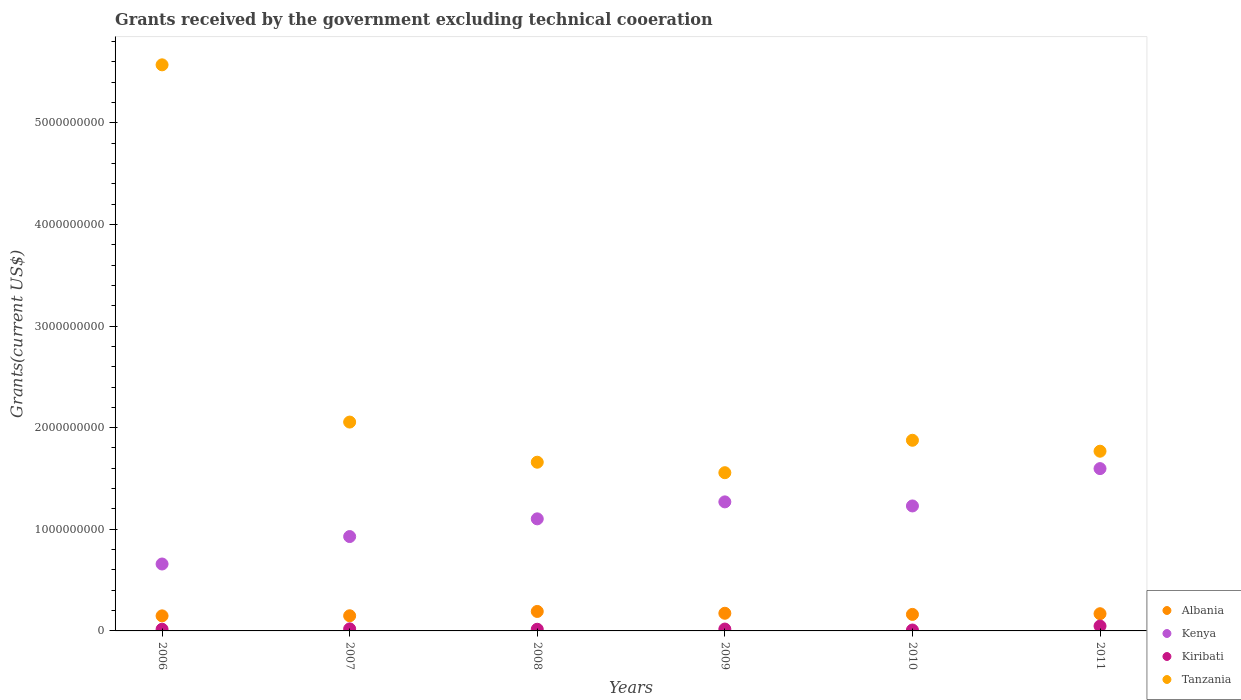How many different coloured dotlines are there?
Make the answer very short. 4. What is the total grants received by the government in Kenya in 2006?
Make the answer very short. 6.58e+08. Across all years, what is the maximum total grants received by the government in Kiribati?
Offer a terse response. 4.79e+07. Across all years, what is the minimum total grants received by the government in Kiribati?
Give a very brief answer. 8.92e+06. What is the total total grants received by the government in Tanzania in the graph?
Provide a succinct answer. 1.45e+1. What is the difference between the total grants received by the government in Albania in 2008 and that in 2009?
Offer a terse response. 1.80e+07. What is the difference between the total grants received by the government in Kenya in 2006 and the total grants received by the government in Albania in 2009?
Your answer should be compact. 4.85e+08. What is the average total grants received by the government in Tanzania per year?
Offer a very short reply. 2.41e+09. In the year 2007, what is the difference between the total grants received by the government in Albania and total grants received by the government in Tanzania?
Ensure brevity in your answer.  -1.91e+09. In how many years, is the total grants received by the government in Tanzania greater than 3200000000 US$?
Make the answer very short. 1. What is the ratio of the total grants received by the government in Kenya in 2007 to that in 2011?
Your response must be concise. 0.58. Is the total grants received by the government in Kenya in 2010 less than that in 2011?
Ensure brevity in your answer.  Yes. What is the difference between the highest and the second highest total grants received by the government in Kiribati?
Keep it short and to the point. 2.77e+07. What is the difference between the highest and the lowest total grants received by the government in Albania?
Offer a very short reply. 4.36e+07. In how many years, is the total grants received by the government in Tanzania greater than the average total grants received by the government in Tanzania taken over all years?
Your response must be concise. 1. Is the sum of the total grants received by the government in Kiribati in 2008 and 2010 greater than the maximum total grants received by the government in Kenya across all years?
Ensure brevity in your answer.  No. Is it the case that in every year, the sum of the total grants received by the government in Kiribati and total grants received by the government in Tanzania  is greater than the total grants received by the government in Albania?
Your answer should be very brief. Yes. Is the total grants received by the government in Tanzania strictly less than the total grants received by the government in Kenya over the years?
Provide a short and direct response. No. How many dotlines are there?
Your answer should be compact. 4. How many years are there in the graph?
Keep it short and to the point. 6. What is the difference between two consecutive major ticks on the Y-axis?
Make the answer very short. 1.00e+09. Does the graph contain grids?
Provide a short and direct response. No. Where does the legend appear in the graph?
Provide a succinct answer. Bottom right. How many legend labels are there?
Your answer should be compact. 4. How are the legend labels stacked?
Provide a short and direct response. Vertical. What is the title of the graph?
Provide a short and direct response. Grants received by the government excluding technical cooeration. Does "Uzbekistan" appear as one of the legend labels in the graph?
Keep it short and to the point. No. What is the label or title of the X-axis?
Offer a very short reply. Years. What is the label or title of the Y-axis?
Provide a succinct answer. Grants(current US$). What is the Grants(current US$) in Albania in 2006?
Give a very brief answer. 1.48e+08. What is the Grants(current US$) of Kenya in 2006?
Make the answer very short. 6.58e+08. What is the Grants(current US$) of Kiribati in 2006?
Offer a very short reply. 1.67e+07. What is the Grants(current US$) of Tanzania in 2006?
Provide a succinct answer. 5.57e+09. What is the Grants(current US$) of Albania in 2007?
Your answer should be very brief. 1.49e+08. What is the Grants(current US$) of Kenya in 2007?
Keep it short and to the point. 9.29e+08. What is the Grants(current US$) of Kiribati in 2007?
Keep it short and to the point. 2.01e+07. What is the Grants(current US$) in Tanzania in 2007?
Offer a very short reply. 2.06e+09. What is the Grants(current US$) of Albania in 2008?
Offer a very short reply. 1.92e+08. What is the Grants(current US$) in Kenya in 2008?
Ensure brevity in your answer.  1.10e+09. What is the Grants(current US$) of Kiribati in 2008?
Make the answer very short. 1.64e+07. What is the Grants(current US$) of Tanzania in 2008?
Your response must be concise. 1.66e+09. What is the Grants(current US$) of Albania in 2009?
Your response must be concise. 1.74e+08. What is the Grants(current US$) of Kenya in 2009?
Make the answer very short. 1.27e+09. What is the Grants(current US$) of Kiribati in 2009?
Provide a short and direct response. 1.83e+07. What is the Grants(current US$) of Tanzania in 2009?
Ensure brevity in your answer.  1.56e+09. What is the Grants(current US$) in Albania in 2010?
Keep it short and to the point. 1.63e+08. What is the Grants(current US$) of Kenya in 2010?
Offer a very short reply. 1.23e+09. What is the Grants(current US$) of Kiribati in 2010?
Your answer should be very brief. 8.92e+06. What is the Grants(current US$) of Tanzania in 2010?
Provide a succinct answer. 1.88e+09. What is the Grants(current US$) in Albania in 2011?
Offer a terse response. 1.69e+08. What is the Grants(current US$) in Kenya in 2011?
Provide a short and direct response. 1.60e+09. What is the Grants(current US$) of Kiribati in 2011?
Give a very brief answer. 4.79e+07. What is the Grants(current US$) of Tanzania in 2011?
Keep it short and to the point. 1.77e+09. Across all years, what is the maximum Grants(current US$) in Albania?
Your response must be concise. 1.92e+08. Across all years, what is the maximum Grants(current US$) in Kenya?
Ensure brevity in your answer.  1.60e+09. Across all years, what is the maximum Grants(current US$) of Kiribati?
Offer a very short reply. 4.79e+07. Across all years, what is the maximum Grants(current US$) in Tanzania?
Keep it short and to the point. 5.57e+09. Across all years, what is the minimum Grants(current US$) of Albania?
Make the answer very short. 1.48e+08. Across all years, what is the minimum Grants(current US$) of Kenya?
Offer a terse response. 6.58e+08. Across all years, what is the minimum Grants(current US$) in Kiribati?
Make the answer very short. 8.92e+06. Across all years, what is the minimum Grants(current US$) of Tanzania?
Your response must be concise. 1.56e+09. What is the total Grants(current US$) of Albania in the graph?
Your answer should be very brief. 9.94e+08. What is the total Grants(current US$) of Kenya in the graph?
Your answer should be very brief. 6.79e+09. What is the total Grants(current US$) in Kiribati in the graph?
Offer a terse response. 1.28e+08. What is the total Grants(current US$) of Tanzania in the graph?
Your response must be concise. 1.45e+1. What is the difference between the Grants(current US$) in Albania in 2006 and that in 2007?
Provide a succinct answer. -9.50e+05. What is the difference between the Grants(current US$) in Kenya in 2006 and that in 2007?
Your answer should be very brief. -2.70e+08. What is the difference between the Grants(current US$) in Kiribati in 2006 and that in 2007?
Your response must be concise. -3.41e+06. What is the difference between the Grants(current US$) in Tanzania in 2006 and that in 2007?
Make the answer very short. 3.52e+09. What is the difference between the Grants(current US$) of Albania in 2006 and that in 2008?
Keep it short and to the point. -4.36e+07. What is the difference between the Grants(current US$) of Kenya in 2006 and that in 2008?
Your answer should be very brief. -4.44e+08. What is the difference between the Grants(current US$) of Tanzania in 2006 and that in 2008?
Your response must be concise. 3.91e+09. What is the difference between the Grants(current US$) of Albania in 2006 and that in 2009?
Keep it short and to the point. -2.55e+07. What is the difference between the Grants(current US$) in Kenya in 2006 and that in 2009?
Keep it short and to the point. -6.11e+08. What is the difference between the Grants(current US$) of Kiribati in 2006 and that in 2009?
Provide a short and direct response. -1.61e+06. What is the difference between the Grants(current US$) in Tanzania in 2006 and that in 2009?
Your response must be concise. 4.01e+09. What is the difference between the Grants(current US$) in Albania in 2006 and that in 2010?
Provide a succinct answer. -1.45e+07. What is the difference between the Grants(current US$) in Kenya in 2006 and that in 2010?
Your answer should be compact. -5.71e+08. What is the difference between the Grants(current US$) of Kiribati in 2006 and that in 2010?
Make the answer very short. 7.81e+06. What is the difference between the Grants(current US$) of Tanzania in 2006 and that in 2010?
Ensure brevity in your answer.  3.69e+09. What is the difference between the Grants(current US$) of Albania in 2006 and that in 2011?
Your answer should be compact. -2.12e+07. What is the difference between the Grants(current US$) of Kenya in 2006 and that in 2011?
Your answer should be very brief. -9.39e+08. What is the difference between the Grants(current US$) of Kiribati in 2006 and that in 2011?
Give a very brief answer. -3.12e+07. What is the difference between the Grants(current US$) in Tanzania in 2006 and that in 2011?
Provide a succinct answer. 3.80e+09. What is the difference between the Grants(current US$) of Albania in 2007 and that in 2008?
Offer a terse response. -4.26e+07. What is the difference between the Grants(current US$) in Kenya in 2007 and that in 2008?
Provide a short and direct response. -1.74e+08. What is the difference between the Grants(current US$) in Kiribati in 2007 and that in 2008?
Offer a terse response. 3.71e+06. What is the difference between the Grants(current US$) of Tanzania in 2007 and that in 2008?
Keep it short and to the point. 3.95e+08. What is the difference between the Grants(current US$) in Albania in 2007 and that in 2009?
Offer a very short reply. -2.46e+07. What is the difference between the Grants(current US$) of Kenya in 2007 and that in 2009?
Provide a short and direct response. -3.41e+08. What is the difference between the Grants(current US$) of Kiribati in 2007 and that in 2009?
Your answer should be compact. 1.80e+06. What is the difference between the Grants(current US$) of Tanzania in 2007 and that in 2009?
Your answer should be very brief. 4.98e+08. What is the difference between the Grants(current US$) in Albania in 2007 and that in 2010?
Provide a short and direct response. -1.35e+07. What is the difference between the Grants(current US$) in Kenya in 2007 and that in 2010?
Make the answer very short. -3.01e+08. What is the difference between the Grants(current US$) in Kiribati in 2007 and that in 2010?
Your answer should be very brief. 1.12e+07. What is the difference between the Grants(current US$) in Tanzania in 2007 and that in 2010?
Offer a very short reply. 1.79e+08. What is the difference between the Grants(current US$) of Albania in 2007 and that in 2011?
Make the answer very short. -2.02e+07. What is the difference between the Grants(current US$) of Kenya in 2007 and that in 2011?
Give a very brief answer. -6.69e+08. What is the difference between the Grants(current US$) of Kiribati in 2007 and that in 2011?
Provide a succinct answer. -2.77e+07. What is the difference between the Grants(current US$) of Tanzania in 2007 and that in 2011?
Ensure brevity in your answer.  2.87e+08. What is the difference between the Grants(current US$) in Albania in 2008 and that in 2009?
Ensure brevity in your answer.  1.80e+07. What is the difference between the Grants(current US$) of Kenya in 2008 and that in 2009?
Offer a very short reply. -1.67e+08. What is the difference between the Grants(current US$) of Kiribati in 2008 and that in 2009?
Offer a terse response. -1.91e+06. What is the difference between the Grants(current US$) of Tanzania in 2008 and that in 2009?
Make the answer very short. 1.03e+08. What is the difference between the Grants(current US$) of Albania in 2008 and that in 2010?
Your answer should be compact. 2.91e+07. What is the difference between the Grants(current US$) in Kenya in 2008 and that in 2010?
Your response must be concise. -1.27e+08. What is the difference between the Grants(current US$) of Kiribati in 2008 and that in 2010?
Ensure brevity in your answer.  7.51e+06. What is the difference between the Grants(current US$) of Tanzania in 2008 and that in 2010?
Your answer should be very brief. -2.16e+08. What is the difference between the Grants(current US$) in Albania in 2008 and that in 2011?
Offer a very short reply. 2.24e+07. What is the difference between the Grants(current US$) in Kenya in 2008 and that in 2011?
Your answer should be very brief. -4.94e+08. What is the difference between the Grants(current US$) of Kiribati in 2008 and that in 2011?
Ensure brevity in your answer.  -3.14e+07. What is the difference between the Grants(current US$) of Tanzania in 2008 and that in 2011?
Your answer should be very brief. -1.08e+08. What is the difference between the Grants(current US$) of Albania in 2009 and that in 2010?
Keep it short and to the point. 1.11e+07. What is the difference between the Grants(current US$) of Kenya in 2009 and that in 2010?
Ensure brevity in your answer.  4.00e+07. What is the difference between the Grants(current US$) of Kiribati in 2009 and that in 2010?
Ensure brevity in your answer.  9.42e+06. What is the difference between the Grants(current US$) in Tanzania in 2009 and that in 2010?
Your response must be concise. -3.19e+08. What is the difference between the Grants(current US$) of Albania in 2009 and that in 2011?
Provide a short and direct response. 4.36e+06. What is the difference between the Grants(current US$) of Kenya in 2009 and that in 2011?
Provide a succinct answer. -3.27e+08. What is the difference between the Grants(current US$) of Kiribati in 2009 and that in 2011?
Give a very brief answer. -2.95e+07. What is the difference between the Grants(current US$) of Tanzania in 2009 and that in 2011?
Ensure brevity in your answer.  -2.11e+08. What is the difference between the Grants(current US$) in Albania in 2010 and that in 2011?
Make the answer very short. -6.71e+06. What is the difference between the Grants(current US$) in Kenya in 2010 and that in 2011?
Offer a terse response. -3.67e+08. What is the difference between the Grants(current US$) in Kiribati in 2010 and that in 2011?
Provide a short and direct response. -3.90e+07. What is the difference between the Grants(current US$) of Tanzania in 2010 and that in 2011?
Keep it short and to the point. 1.08e+08. What is the difference between the Grants(current US$) of Albania in 2006 and the Grants(current US$) of Kenya in 2007?
Your answer should be very brief. -7.80e+08. What is the difference between the Grants(current US$) of Albania in 2006 and the Grants(current US$) of Kiribati in 2007?
Your answer should be very brief. 1.28e+08. What is the difference between the Grants(current US$) of Albania in 2006 and the Grants(current US$) of Tanzania in 2007?
Offer a very short reply. -1.91e+09. What is the difference between the Grants(current US$) of Kenya in 2006 and the Grants(current US$) of Kiribati in 2007?
Provide a short and direct response. 6.38e+08. What is the difference between the Grants(current US$) in Kenya in 2006 and the Grants(current US$) in Tanzania in 2007?
Your answer should be very brief. -1.40e+09. What is the difference between the Grants(current US$) of Kiribati in 2006 and the Grants(current US$) of Tanzania in 2007?
Your answer should be very brief. -2.04e+09. What is the difference between the Grants(current US$) in Albania in 2006 and the Grants(current US$) in Kenya in 2008?
Give a very brief answer. -9.55e+08. What is the difference between the Grants(current US$) in Albania in 2006 and the Grants(current US$) in Kiribati in 2008?
Provide a short and direct response. 1.32e+08. What is the difference between the Grants(current US$) of Albania in 2006 and the Grants(current US$) of Tanzania in 2008?
Provide a succinct answer. -1.51e+09. What is the difference between the Grants(current US$) of Kenya in 2006 and the Grants(current US$) of Kiribati in 2008?
Keep it short and to the point. 6.42e+08. What is the difference between the Grants(current US$) in Kenya in 2006 and the Grants(current US$) in Tanzania in 2008?
Your answer should be compact. -1.00e+09. What is the difference between the Grants(current US$) of Kiribati in 2006 and the Grants(current US$) of Tanzania in 2008?
Make the answer very short. -1.64e+09. What is the difference between the Grants(current US$) in Albania in 2006 and the Grants(current US$) in Kenya in 2009?
Offer a terse response. -1.12e+09. What is the difference between the Grants(current US$) in Albania in 2006 and the Grants(current US$) in Kiribati in 2009?
Your response must be concise. 1.30e+08. What is the difference between the Grants(current US$) in Albania in 2006 and the Grants(current US$) in Tanzania in 2009?
Offer a very short reply. -1.41e+09. What is the difference between the Grants(current US$) of Kenya in 2006 and the Grants(current US$) of Kiribati in 2009?
Make the answer very short. 6.40e+08. What is the difference between the Grants(current US$) of Kenya in 2006 and the Grants(current US$) of Tanzania in 2009?
Your answer should be very brief. -8.98e+08. What is the difference between the Grants(current US$) of Kiribati in 2006 and the Grants(current US$) of Tanzania in 2009?
Provide a short and direct response. -1.54e+09. What is the difference between the Grants(current US$) of Albania in 2006 and the Grants(current US$) of Kenya in 2010?
Offer a terse response. -1.08e+09. What is the difference between the Grants(current US$) in Albania in 2006 and the Grants(current US$) in Kiribati in 2010?
Offer a terse response. 1.39e+08. What is the difference between the Grants(current US$) of Albania in 2006 and the Grants(current US$) of Tanzania in 2010?
Provide a succinct answer. -1.73e+09. What is the difference between the Grants(current US$) in Kenya in 2006 and the Grants(current US$) in Kiribati in 2010?
Your answer should be compact. 6.50e+08. What is the difference between the Grants(current US$) of Kenya in 2006 and the Grants(current US$) of Tanzania in 2010?
Your answer should be compact. -1.22e+09. What is the difference between the Grants(current US$) in Kiribati in 2006 and the Grants(current US$) in Tanzania in 2010?
Your response must be concise. -1.86e+09. What is the difference between the Grants(current US$) of Albania in 2006 and the Grants(current US$) of Kenya in 2011?
Your response must be concise. -1.45e+09. What is the difference between the Grants(current US$) in Albania in 2006 and the Grants(current US$) in Kiribati in 2011?
Keep it short and to the point. 1.00e+08. What is the difference between the Grants(current US$) of Albania in 2006 and the Grants(current US$) of Tanzania in 2011?
Offer a very short reply. -1.62e+09. What is the difference between the Grants(current US$) of Kenya in 2006 and the Grants(current US$) of Kiribati in 2011?
Give a very brief answer. 6.11e+08. What is the difference between the Grants(current US$) of Kenya in 2006 and the Grants(current US$) of Tanzania in 2011?
Keep it short and to the point. -1.11e+09. What is the difference between the Grants(current US$) of Kiribati in 2006 and the Grants(current US$) of Tanzania in 2011?
Your answer should be compact. -1.75e+09. What is the difference between the Grants(current US$) of Albania in 2007 and the Grants(current US$) of Kenya in 2008?
Your answer should be compact. -9.54e+08. What is the difference between the Grants(current US$) in Albania in 2007 and the Grants(current US$) in Kiribati in 2008?
Keep it short and to the point. 1.33e+08. What is the difference between the Grants(current US$) in Albania in 2007 and the Grants(current US$) in Tanzania in 2008?
Offer a very short reply. -1.51e+09. What is the difference between the Grants(current US$) in Kenya in 2007 and the Grants(current US$) in Kiribati in 2008?
Make the answer very short. 9.12e+08. What is the difference between the Grants(current US$) of Kenya in 2007 and the Grants(current US$) of Tanzania in 2008?
Offer a terse response. -7.31e+08. What is the difference between the Grants(current US$) of Kiribati in 2007 and the Grants(current US$) of Tanzania in 2008?
Keep it short and to the point. -1.64e+09. What is the difference between the Grants(current US$) in Albania in 2007 and the Grants(current US$) in Kenya in 2009?
Offer a terse response. -1.12e+09. What is the difference between the Grants(current US$) of Albania in 2007 and the Grants(current US$) of Kiribati in 2009?
Keep it short and to the point. 1.31e+08. What is the difference between the Grants(current US$) in Albania in 2007 and the Grants(current US$) in Tanzania in 2009?
Provide a succinct answer. -1.41e+09. What is the difference between the Grants(current US$) in Kenya in 2007 and the Grants(current US$) in Kiribati in 2009?
Provide a short and direct response. 9.10e+08. What is the difference between the Grants(current US$) of Kenya in 2007 and the Grants(current US$) of Tanzania in 2009?
Give a very brief answer. -6.28e+08. What is the difference between the Grants(current US$) in Kiribati in 2007 and the Grants(current US$) in Tanzania in 2009?
Give a very brief answer. -1.54e+09. What is the difference between the Grants(current US$) of Albania in 2007 and the Grants(current US$) of Kenya in 2010?
Your response must be concise. -1.08e+09. What is the difference between the Grants(current US$) in Albania in 2007 and the Grants(current US$) in Kiribati in 2010?
Keep it short and to the point. 1.40e+08. What is the difference between the Grants(current US$) of Albania in 2007 and the Grants(current US$) of Tanzania in 2010?
Ensure brevity in your answer.  -1.73e+09. What is the difference between the Grants(current US$) of Kenya in 2007 and the Grants(current US$) of Kiribati in 2010?
Give a very brief answer. 9.20e+08. What is the difference between the Grants(current US$) in Kenya in 2007 and the Grants(current US$) in Tanzania in 2010?
Your answer should be very brief. -9.47e+08. What is the difference between the Grants(current US$) of Kiribati in 2007 and the Grants(current US$) of Tanzania in 2010?
Provide a succinct answer. -1.86e+09. What is the difference between the Grants(current US$) in Albania in 2007 and the Grants(current US$) in Kenya in 2011?
Provide a succinct answer. -1.45e+09. What is the difference between the Grants(current US$) in Albania in 2007 and the Grants(current US$) in Kiribati in 2011?
Provide a succinct answer. 1.01e+08. What is the difference between the Grants(current US$) in Albania in 2007 and the Grants(current US$) in Tanzania in 2011?
Provide a short and direct response. -1.62e+09. What is the difference between the Grants(current US$) in Kenya in 2007 and the Grants(current US$) in Kiribati in 2011?
Ensure brevity in your answer.  8.81e+08. What is the difference between the Grants(current US$) of Kenya in 2007 and the Grants(current US$) of Tanzania in 2011?
Keep it short and to the point. -8.40e+08. What is the difference between the Grants(current US$) in Kiribati in 2007 and the Grants(current US$) in Tanzania in 2011?
Offer a terse response. -1.75e+09. What is the difference between the Grants(current US$) of Albania in 2008 and the Grants(current US$) of Kenya in 2009?
Give a very brief answer. -1.08e+09. What is the difference between the Grants(current US$) in Albania in 2008 and the Grants(current US$) in Kiribati in 2009?
Offer a very short reply. 1.73e+08. What is the difference between the Grants(current US$) of Albania in 2008 and the Grants(current US$) of Tanzania in 2009?
Provide a short and direct response. -1.37e+09. What is the difference between the Grants(current US$) of Kenya in 2008 and the Grants(current US$) of Kiribati in 2009?
Provide a succinct answer. 1.08e+09. What is the difference between the Grants(current US$) of Kenya in 2008 and the Grants(current US$) of Tanzania in 2009?
Your answer should be very brief. -4.54e+08. What is the difference between the Grants(current US$) in Kiribati in 2008 and the Grants(current US$) in Tanzania in 2009?
Keep it short and to the point. -1.54e+09. What is the difference between the Grants(current US$) of Albania in 2008 and the Grants(current US$) of Kenya in 2010?
Offer a terse response. -1.04e+09. What is the difference between the Grants(current US$) in Albania in 2008 and the Grants(current US$) in Kiribati in 2010?
Offer a terse response. 1.83e+08. What is the difference between the Grants(current US$) in Albania in 2008 and the Grants(current US$) in Tanzania in 2010?
Your response must be concise. -1.68e+09. What is the difference between the Grants(current US$) in Kenya in 2008 and the Grants(current US$) in Kiribati in 2010?
Offer a terse response. 1.09e+09. What is the difference between the Grants(current US$) in Kenya in 2008 and the Grants(current US$) in Tanzania in 2010?
Your answer should be very brief. -7.73e+08. What is the difference between the Grants(current US$) of Kiribati in 2008 and the Grants(current US$) of Tanzania in 2010?
Provide a succinct answer. -1.86e+09. What is the difference between the Grants(current US$) in Albania in 2008 and the Grants(current US$) in Kenya in 2011?
Offer a very short reply. -1.41e+09. What is the difference between the Grants(current US$) in Albania in 2008 and the Grants(current US$) in Kiribati in 2011?
Offer a terse response. 1.44e+08. What is the difference between the Grants(current US$) in Albania in 2008 and the Grants(current US$) in Tanzania in 2011?
Give a very brief answer. -1.58e+09. What is the difference between the Grants(current US$) of Kenya in 2008 and the Grants(current US$) of Kiribati in 2011?
Keep it short and to the point. 1.05e+09. What is the difference between the Grants(current US$) of Kenya in 2008 and the Grants(current US$) of Tanzania in 2011?
Provide a short and direct response. -6.66e+08. What is the difference between the Grants(current US$) of Kiribati in 2008 and the Grants(current US$) of Tanzania in 2011?
Keep it short and to the point. -1.75e+09. What is the difference between the Grants(current US$) of Albania in 2009 and the Grants(current US$) of Kenya in 2010?
Your answer should be compact. -1.06e+09. What is the difference between the Grants(current US$) in Albania in 2009 and the Grants(current US$) in Kiribati in 2010?
Keep it short and to the point. 1.65e+08. What is the difference between the Grants(current US$) in Albania in 2009 and the Grants(current US$) in Tanzania in 2010?
Your response must be concise. -1.70e+09. What is the difference between the Grants(current US$) in Kenya in 2009 and the Grants(current US$) in Kiribati in 2010?
Make the answer very short. 1.26e+09. What is the difference between the Grants(current US$) in Kenya in 2009 and the Grants(current US$) in Tanzania in 2010?
Provide a succinct answer. -6.06e+08. What is the difference between the Grants(current US$) of Kiribati in 2009 and the Grants(current US$) of Tanzania in 2010?
Make the answer very short. -1.86e+09. What is the difference between the Grants(current US$) in Albania in 2009 and the Grants(current US$) in Kenya in 2011?
Offer a terse response. -1.42e+09. What is the difference between the Grants(current US$) of Albania in 2009 and the Grants(current US$) of Kiribati in 2011?
Your answer should be very brief. 1.26e+08. What is the difference between the Grants(current US$) of Albania in 2009 and the Grants(current US$) of Tanzania in 2011?
Offer a terse response. -1.59e+09. What is the difference between the Grants(current US$) of Kenya in 2009 and the Grants(current US$) of Kiribati in 2011?
Ensure brevity in your answer.  1.22e+09. What is the difference between the Grants(current US$) in Kenya in 2009 and the Grants(current US$) in Tanzania in 2011?
Provide a succinct answer. -4.99e+08. What is the difference between the Grants(current US$) in Kiribati in 2009 and the Grants(current US$) in Tanzania in 2011?
Offer a terse response. -1.75e+09. What is the difference between the Grants(current US$) of Albania in 2010 and the Grants(current US$) of Kenya in 2011?
Your answer should be very brief. -1.43e+09. What is the difference between the Grants(current US$) of Albania in 2010 and the Grants(current US$) of Kiribati in 2011?
Your answer should be very brief. 1.15e+08. What is the difference between the Grants(current US$) of Albania in 2010 and the Grants(current US$) of Tanzania in 2011?
Provide a short and direct response. -1.61e+09. What is the difference between the Grants(current US$) of Kenya in 2010 and the Grants(current US$) of Kiribati in 2011?
Your response must be concise. 1.18e+09. What is the difference between the Grants(current US$) of Kenya in 2010 and the Grants(current US$) of Tanzania in 2011?
Offer a very short reply. -5.39e+08. What is the difference between the Grants(current US$) in Kiribati in 2010 and the Grants(current US$) in Tanzania in 2011?
Provide a succinct answer. -1.76e+09. What is the average Grants(current US$) of Albania per year?
Offer a very short reply. 1.66e+08. What is the average Grants(current US$) of Kenya per year?
Offer a very short reply. 1.13e+09. What is the average Grants(current US$) of Kiribati per year?
Your response must be concise. 2.14e+07. What is the average Grants(current US$) in Tanzania per year?
Make the answer very short. 2.41e+09. In the year 2006, what is the difference between the Grants(current US$) in Albania and Grants(current US$) in Kenya?
Your answer should be compact. -5.10e+08. In the year 2006, what is the difference between the Grants(current US$) of Albania and Grants(current US$) of Kiribati?
Your response must be concise. 1.31e+08. In the year 2006, what is the difference between the Grants(current US$) in Albania and Grants(current US$) in Tanzania?
Offer a very short reply. -5.42e+09. In the year 2006, what is the difference between the Grants(current US$) in Kenya and Grants(current US$) in Kiribati?
Your response must be concise. 6.42e+08. In the year 2006, what is the difference between the Grants(current US$) in Kenya and Grants(current US$) in Tanzania?
Provide a succinct answer. -4.91e+09. In the year 2006, what is the difference between the Grants(current US$) of Kiribati and Grants(current US$) of Tanzania?
Keep it short and to the point. -5.55e+09. In the year 2007, what is the difference between the Grants(current US$) of Albania and Grants(current US$) of Kenya?
Your answer should be very brief. -7.79e+08. In the year 2007, what is the difference between the Grants(current US$) of Albania and Grants(current US$) of Kiribati?
Your response must be concise. 1.29e+08. In the year 2007, what is the difference between the Grants(current US$) in Albania and Grants(current US$) in Tanzania?
Your response must be concise. -1.91e+09. In the year 2007, what is the difference between the Grants(current US$) of Kenya and Grants(current US$) of Kiribati?
Offer a very short reply. 9.08e+08. In the year 2007, what is the difference between the Grants(current US$) of Kenya and Grants(current US$) of Tanzania?
Give a very brief answer. -1.13e+09. In the year 2007, what is the difference between the Grants(current US$) of Kiribati and Grants(current US$) of Tanzania?
Your answer should be very brief. -2.03e+09. In the year 2008, what is the difference between the Grants(current US$) of Albania and Grants(current US$) of Kenya?
Keep it short and to the point. -9.11e+08. In the year 2008, what is the difference between the Grants(current US$) of Albania and Grants(current US$) of Kiribati?
Ensure brevity in your answer.  1.75e+08. In the year 2008, what is the difference between the Grants(current US$) in Albania and Grants(current US$) in Tanzania?
Your answer should be very brief. -1.47e+09. In the year 2008, what is the difference between the Grants(current US$) in Kenya and Grants(current US$) in Kiribati?
Provide a short and direct response. 1.09e+09. In the year 2008, what is the difference between the Grants(current US$) of Kenya and Grants(current US$) of Tanzania?
Your answer should be compact. -5.57e+08. In the year 2008, what is the difference between the Grants(current US$) in Kiribati and Grants(current US$) in Tanzania?
Make the answer very short. -1.64e+09. In the year 2009, what is the difference between the Grants(current US$) of Albania and Grants(current US$) of Kenya?
Offer a very short reply. -1.10e+09. In the year 2009, what is the difference between the Grants(current US$) of Albania and Grants(current US$) of Kiribati?
Your answer should be compact. 1.55e+08. In the year 2009, what is the difference between the Grants(current US$) of Albania and Grants(current US$) of Tanzania?
Your answer should be compact. -1.38e+09. In the year 2009, what is the difference between the Grants(current US$) of Kenya and Grants(current US$) of Kiribati?
Make the answer very short. 1.25e+09. In the year 2009, what is the difference between the Grants(current US$) in Kenya and Grants(current US$) in Tanzania?
Give a very brief answer. -2.87e+08. In the year 2009, what is the difference between the Grants(current US$) in Kiribati and Grants(current US$) in Tanzania?
Keep it short and to the point. -1.54e+09. In the year 2010, what is the difference between the Grants(current US$) of Albania and Grants(current US$) of Kenya?
Your answer should be compact. -1.07e+09. In the year 2010, what is the difference between the Grants(current US$) of Albania and Grants(current US$) of Kiribati?
Provide a succinct answer. 1.54e+08. In the year 2010, what is the difference between the Grants(current US$) of Albania and Grants(current US$) of Tanzania?
Ensure brevity in your answer.  -1.71e+09. In the year 2010, what is the difference between the Grants(current US$) of Kenya and Grants(current US$) of Kiribati?
Your answer should be compact. 1.22e+09. In the year 2010, what is the difference between the Grants(current US$) of Kenya and Grants(current US$) of Tanzania?
Give a very brief answer. -6.46e+08. In the year 2010, what is the difference between the Grants(current US$) of Kiribati and Grants(current US$) of Tanzania?
Give a very brief answer. -1.87e+09. In the year 2011, what is the difference between the Grants(current US$) in Albania and Grants(current US$) in Kenya?
Keep it short and to the point. -1.43e+09. In the year 2011, what is the difference between the Grants(current US$) of Albania and Grants(current US$) of Kiribati?
Make the answer very short. 1.21e+08. In the year 2011, what is the difference between the Grants(current US$) of Albania and Grants(current US$) of Tanzania?
Keep it short and to the point. -1.60e+09. In the year 2011, what is the difference between the Grants(current US$) of Kenya and Grants(current US$) of Kiribati?
Make the answer very short. 1.55e+09. In the year 2011, what is the difference between the Grants(current US$) in Kenya and Grants(current US$) in Tanzania?
Offer a very short reply. -1.71e+08. In the year 2011, what is the difference between the Grants(current US$) in Kiribati and Grants(current US$) in Tanzania?
Ensure brevity in your answer.  -1.72e+09. What is the ratio of the Grants(current US$) of Kenya in 2006 to that in 2007?
Offer a very short reply. 0.71. What is the ratio of the Grants(current US$) in Kiribati in 2006 to that in 2007?
Offer a very short reply. 0.83. What is the ratio of the Grants(current US$) in Tanzania in 2006 to that in 2007?
Your answer should be compact. 2.71. What is the ratio of the Grants(current US$) of Albania in 2006 to that in 2008?
Offer a terse response. 0.77. What is the ratio of the Grants(current US$) of Kenya in 2006 to that in 2008?
Keep it short and to the point. 0.6. What is the ratio of the Grants(current US$) of Kiribati in 2006 to that in 2008?
Ensure brevity in your answer.  1.02. What is the ratio of the Grants(current US$) in Tanzania in 2006 to that in 2008?
Your response must be concise. 3.36. What is the ratio of the Grants(current US$) of Albania in 2006 to that in 2009?
Give a very brief answer. 0.85. What is the ratio of the Grants(current US$) of Kenya in 2006 to that in 2009?
Your answer should be very brief. 0.52. What is the ratio of the Grants(current US$) in Kiribati in 2006 to that in 2009?
Keep it short and to the point. 0.91. What is the ratio of the Grants(current US$) in Tanzania in 2006 to that in 2009?
Offer a terse response. 3.58. What is the ratio of the Grants(current US$) of Albania in 2006 to that in 2010?
Keep it short and to the point. 0.91. What is the ratio of the Grants(current US$) in Kenya in 2006 to that in 2010?
Keep it short and to the point. 0.54. What is the ratio of the Grants(current US$) of Kiribati in 2006 to that in 2010?
Ensure brevity in your answer.  1.88. What is the ratio of the Grants(current US$) of Tanzania in 2006 to that in 2010?
Keep it short and to the point. 2.97. What is the ratio of the Grants(current US$) in Albania in 2006 to that in 2011?
Provide a short and direct response. 0.87. What is the ratio of the Grants(current US$) in Kenya in 2006 to that in 2011?
Provide a succinct answer. 0.41. What is the ratio of the Grants(current US$) of Kiribati in 2006 to that in 2011?
Keep it short and to the point. 0.35. What is the ratio of the Grants(current US$) of Tanzania in 2006 to that in 2011?
Your answer should be very brief. 3.15. What is the ratio of the Grants(current US$) of Albania in 2007 to that in 2008?
Offer a terse response. 0.78. What is the ratio of the Grants(current US$) in Kenya in 2007 to that in 2008?
Make the answer very short. 0.84. What is the ratio of the Grants(current US$) of Kiribati in 2007 to that in 2008?
Offer a very short reply. 1.23. What is the ratio of the Grants(current US$) of Tanzania in 2007 to that in 2008?
Your response must be concise. 1.24. What is the ratio of the Grants(current US$) of Albania in 2007 to that in 2009?
Offer a terse response. 0.86. What is the ratio of the Grants(current US$) of Kenya in 2007 to that in 2009?
Your answer should be very brief. 0.73. What is the ratio of the Grants(current US$) of Kiribati in 2007 to that in 2009?
Your answer should be very brief. 1.1. What is the ratio of the Grants(current US$) of Tanzania in 2007 to that in 2009?
Make the answer very short. 1.32. What is the ratio of the Grants(current US$) in Albania in 2007 to that in 2010?
Provide a succinct answer. 0.92. What is the ratio of the Grants(current US$) of Kenya in 2007 to that in 2010?
Your answer should be very brief. 0.76. What is the ratio of the Grants(current US$) of Kiribati in 2007 to that in 2010?
Keep it short and to the point. 2.26. What is the ratio of the Grants(current US$) of Tanzania in 2007 to that in 2010?
Ensure brevity in your answer.  1.1. What is the ratio of the Grants(current US$) of Albania in 2007 to that in 2011?
Give a very brief answer. 0.88. What is the ratio of the Grants(current US$) in Kenya in 2007 to that in 2011?
Make the answer very short. 0.58. What is the ratio of the Grants(current US$) of Kiribati in 2007 to that in 2011?
Offer a terse response. 0.42. What is the ratio of the Grants(current US$) of Tanzania in 2007 to that in 2011?
Give a very brief answer. 1.16. What is the ratio of the Grants(current US$) of Albania in 2008 to that in 2009?
Make the answer very short. 1.1. What is the ratio of the Grants(current US$) in Kenya in 2008 to that in 2009?
Give a very brief answer. 0.87. What is the ratio of the Grants(current US$) of Kiribati in 2008 to that in 2009?
Make the answer very short. 0.9. What is the ratio of the Grants(current US$) of Tanzania in 2008 to that in 2009?
Your answer should be very brief. 1.07. What is the ratio of the Grants(current US$) in Albania in 2008 to that in 2010?
Ensure brevity in your answer.  1.18. What is the ratio of the Grants(current US$) of Kenya in 2008 to that in 2010?
Keep it short and to the point. 0.9. What is the ratio of the Grants(current US$) in Kiribati in 2008 to that in 2010?
Your response must be concise. 1.84. What is the ratio of the Grants(current US$) of Tanzania in 2008 to that in 2010?
Your answer should be compact. 0.88. What is the ratio of the Grants(current US$) of Albania in 2008 to that in 2011?
Offer a terse response. 1.13. What is the ratio of the Grants(current US$) in Kenya in 2008 to that in 2011?
Offer a very short reply. 0.69. What is the ratio of the Grants(current US$) in Kiribati in 2008 to that in 2011?
Make the answer very short. 0.34. What is the ratio of the Grants(current US$) in Tanzania in 2008 to that in 2011?
Keep it short and to the point. 0.94. What is the ratio of the Grants(current US$) in Albania in 2009 to that in 2010?
Offer a very short reply. 1.07. What is the ratio of the Grants(current US$) in Kenya in 2009 to that in 2010?
Provide a short and direct response. 1.03. What is the ratio of the Grants(current US$) of Kiribati in 2009 to that in 2010?
Make the answer very short. 2.06. What is the ratio of the Grants(current US$) in Tanzania in 2009 to that in 2010?
Provide a succinct answer. 0.83. What is the ratio of the Grants(current US$) in Albania in 2009 to that in 2011?
Keep it short and to the point. 1.03. What is the ratio of the Grants(current US$) in Kenya in 2009 to that in 2011?
Keep it short and to the point. 0.8. What is the ratio of the Grants(current US$) of Kiribati in 2009 to that in 2011?
Offer a terse response. 0.38. What is the ratio of the Grants(current US$) in Tanzania in 2009 to that in 2011?
Provide a succinct answer. 0.88. What is the ratio of the Grants(current US$) of Albania in 2010 to that in 2011?
Your response must be concise. 0.96. What is the ratio of the Grants(current US$) of Kenya in 2010 to that in 2011?
Your answer should be compact. 0.77. What is the ratio of the Grants(current US$) in Kiribati in 2010 to that in 2011?
Ensure brevity in your answer.  0.19. What is the ratio of the Grants(current US$) of Tanzania in 2010 to that in 2011?
Your response must be concise. 1.06. What is the difference between the highest and the second highest Grants(current US$) in Albania?
Your answer should be compact. 1.80e+07. What is the difference between the highest and the second highest Grants(current US$) of Kenya?
Offer a very short reply. 3.27e+08. What is the difference between the highest and the second highest Grants(current US$) in Kiribati?
Your response must be concise. 2.77e+07. What is the difference between the highest and the second highest Grants(current US$) of Tanzania?
Give a very brief answer. 3.52e+09. What is the difference between the highest and the lowest Grants(current US$) in Albania?
Provide a short and direct response. 4.36e+07. What is the difference between the highest and the lowest Grants(current US$) of Kenya?
Make the answer very short. 9.39e+08. What is the difference between the highest and the lowest Grants(current US$) of Kiribati?
Provide a succinct answer. 3.90e+07. What is the difference between the highest and the lowest Grants(current US$) in Tanzania?
Keep it short and to the point. 4.01e+09. 